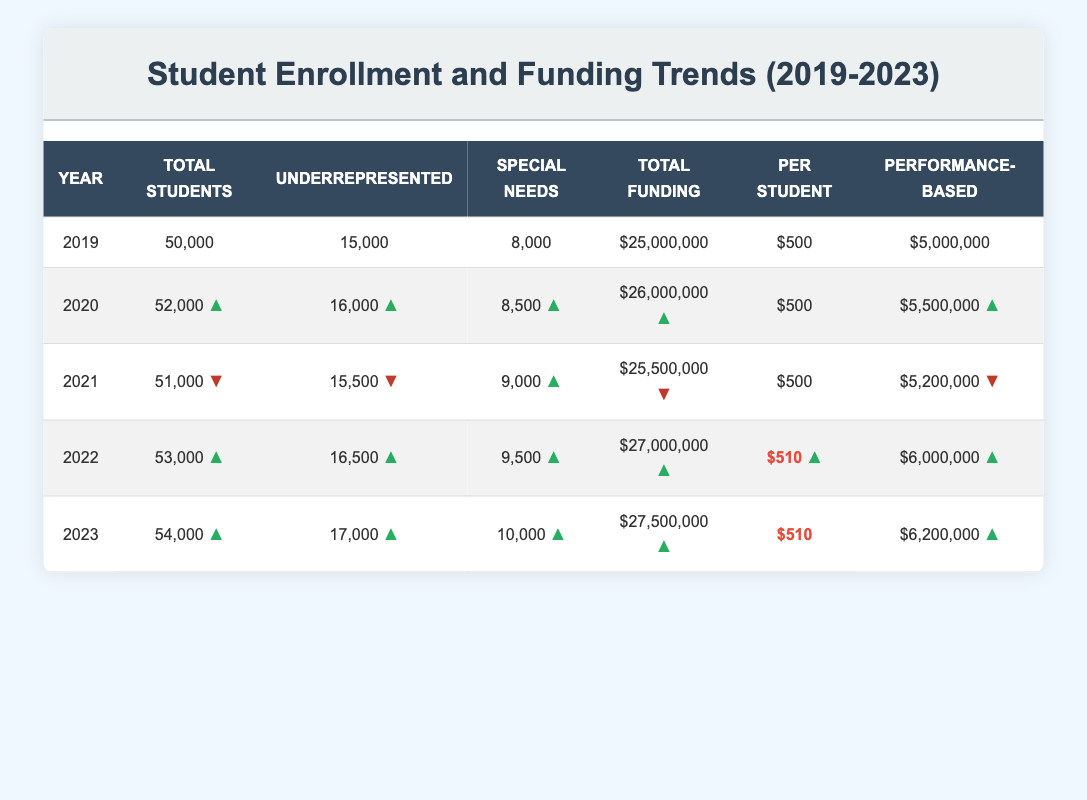What was the total funding for the year 2021? The table clearly shows the funding details for each year. By locating the row for 2021, we see that the total funding is listed as $25,500,000.
Answer: $25,500,000 How many total students were enrolled in 2022? Referring to the table, the total number of students enrolled in 2022 is found in the respective row. The data shows 53,000 total students for that year.
Answer: 53,000 What is the difference in total funding between 2019 and 2023? First, we must identify the total funding for both years from the table: 2019 shows $25,000,000 and 2023 shows $27,500,000. We calculate the difference as $27,500,000 - $25,000,000 = $2,500,000.
Answer: $2,500,000 Did the number of underrepresented students increase from 2019 to 2022? We compare the figures for underrepresented students in both years: in 2019, there were 15,000 underrepresented students, and in 2022, there were 16,500. Since 16,500 is greater than 15,000, it indicates an increase.
Answer: Yes What is the average funding per student from 2019 to 2023? To calculate the average funding per student, we first gather the per-student funding for each year: $500 (2019), $500 (2020), $500 (2021), $510 (2022), and $510 (2023). The sum of these amounts is $500 + $500 + $500 + $510 + $510 = $2520. We then divide by the number of years (5), which gives us $2520 / 5 = $504.
Answer: $504 In which year was the performance-based funding the highest? Reviewing the performance-based funding for each year: $5,000,000 (2019), $5,500,000 (2020), $5,200,000 (2021), $6,000,000 (2022), and $6,200,000 (2023), we identify that 2023 has the highest at $6,200,000, thus indicating that this year has the peak funding amount.
Answer: 2023 What trend do we see in the enrollment of special needs students from 2019 to 2023? By looking at the special needs students over the years, we observe the numbers: 8,000 (2019), 8,500 (2020), 9,000 (2021), 9,500 (2022), and 10,000 (2023). Each subsequent year shows an increase. Therefore, we conclude that there is a consistent increasing trend in special needs student enrollment.
Answer: Constant increase Was there a decrease in the total number of students enrolled from 2020 to 2021? We need to compare the total enrollments of the two years: 52,000 (2020) and 51,000 (2021). Since 51,000 is less than 52,000, this indicates there was a decrease in enrollment.
Answer: Yes 